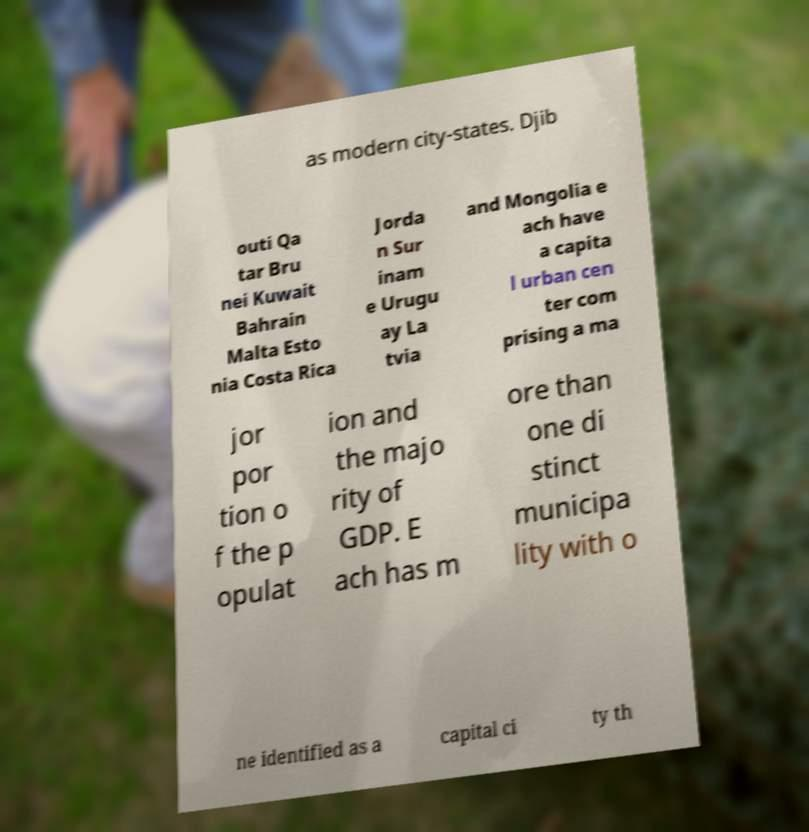Can you read and provide the text displayed in the image?This photo seems to have some interesting text. Can you extract and type it out for me? as modern city-states. Djib outi Qa tar Bru nei Kuwait Bahrain Malta Esto nia Costa Rica Jorda n Sur inam e Urugu ay La tvia and Mongolia e ach have a capita l urban cen ter com prising a ma jor por tion o f the p opulat ion and the majo rity of GDP. E ach has m ore than one di stinct municipa lity with o ne identified as a capital ci ty th 